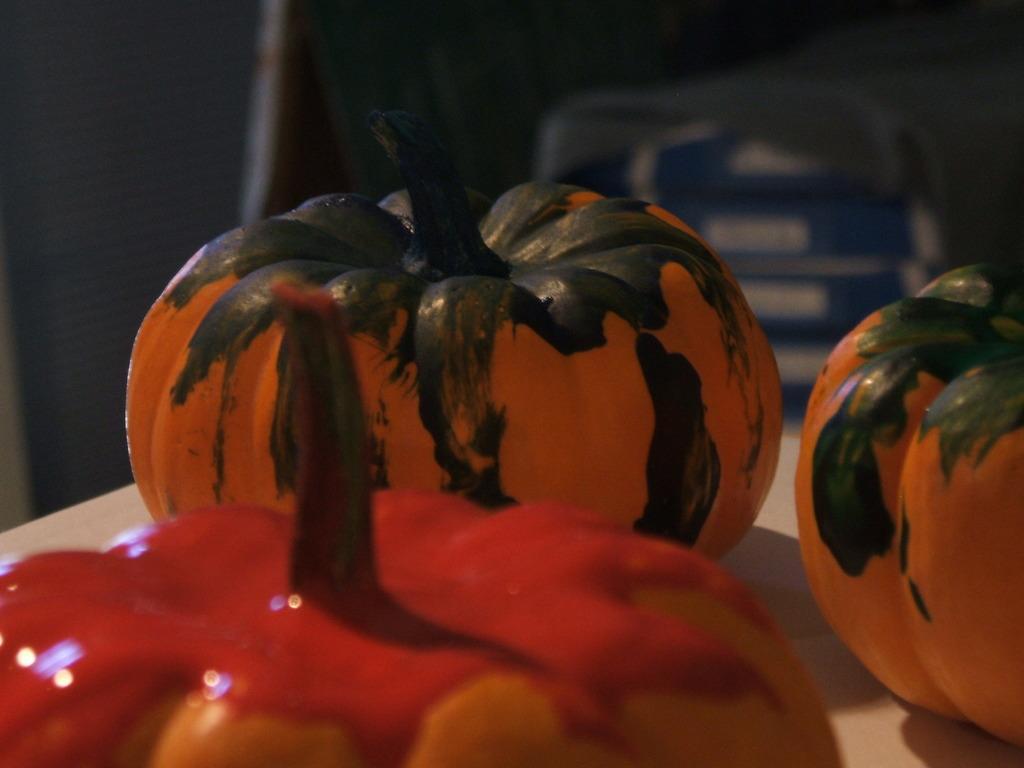Describe this image in one or two sentences. We can see pumpkins on the table. In the background it is blur. 